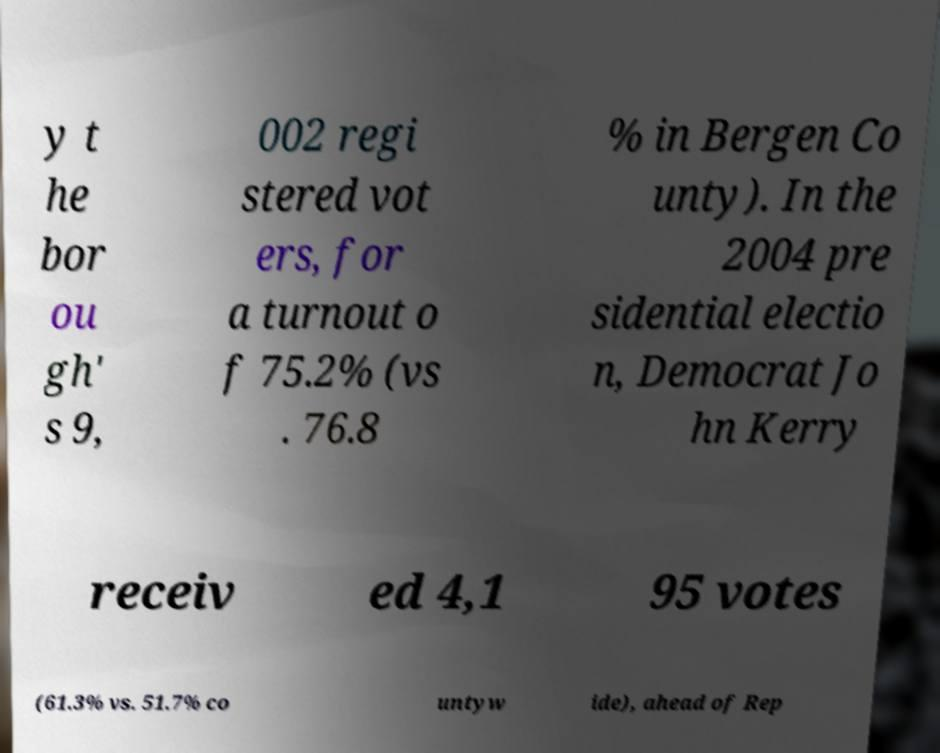Please read and relay the text visible in this image. What does it say? y t he bor ou gh' s 9, 002 regi stered vot ers, for a turnout o f 75.2% (vs . 76.8 % in Bergen Co unty). In the 2004 pre sidential electio n, Democrat Jo hn Kerry receiv ed 4,1 95 votes (61.3% vs. 51.7% co untyw ide), ahead of Rep 